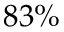Convert formula to latex. <formula><loc_0><loc_0><loc_500><loc_500>8 3 \%</formula> 